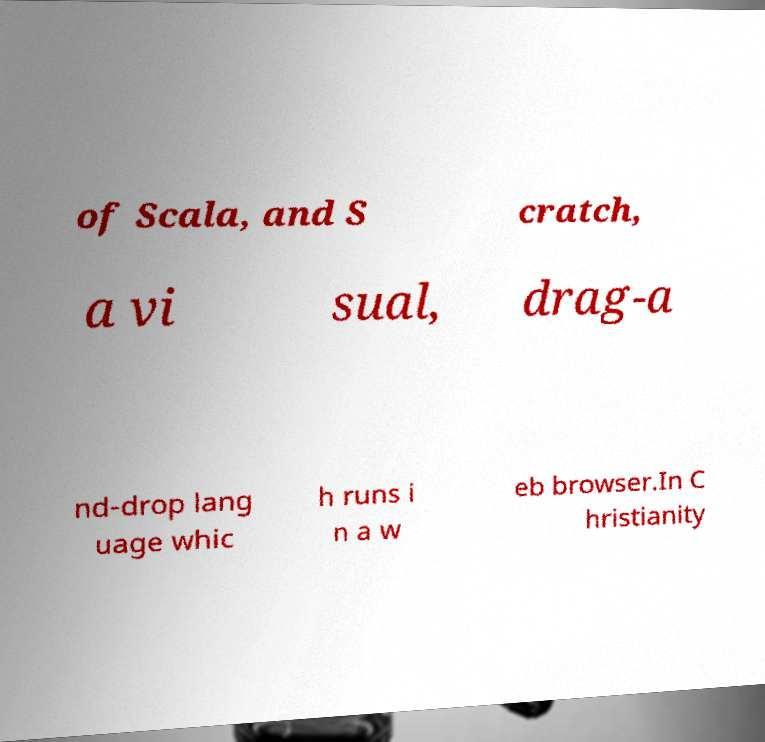For documentation purposes, I need the text within this image transcribed. Could you provide that? of Scala, and S cratch, a vi sual, drag-a nd-drop lang uage whic h runs i n a w eb browser.In C hristianity 